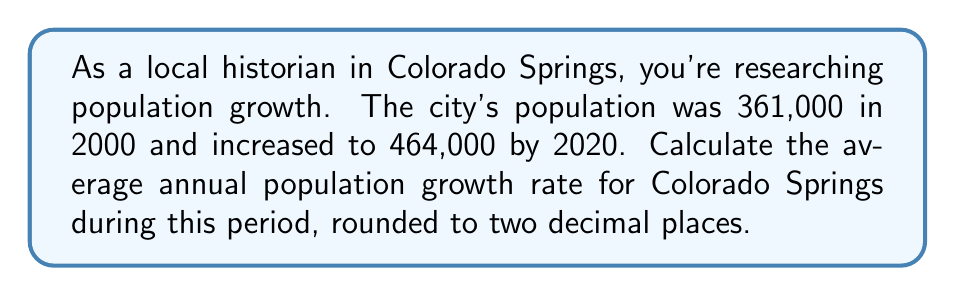Help me with this question. To calculate the average annual population growth rate, we'll use the compound annual growth rate (CAGR) formula:

$$ CAGR = \left(\frac{Ending Value}{Beginning Value}\right)^{\frac{1}{n}} - 1 $$

Where:
- Ending Value = 464,000 (2020 population)
- Beginning Value = 361,000 (2000 population)
- n = 20 (number of years between 2000 and 2020)

Step 1: Insert the values into the formula:
$$ CAGR = \left(\frac{464,000}{361,000}\right)^{\frac{1}{20}} - 1 $$

Step 2: Simplify the fraction inside the parentheses:
$$ CAGR = (1.2853)^{\frac{1}{20}} - 1 $$

Step 3: Calculate the 20th root:
$$ CAGR = 1.0126 - 1 $$

Step 4: Subtract 1:
$$ CAGR = 0.0126 $$

Step 5: Convert to a percentage and round to two decimal places:
$$ CAGR = 1.26\% $$
Answer: 1.26% 